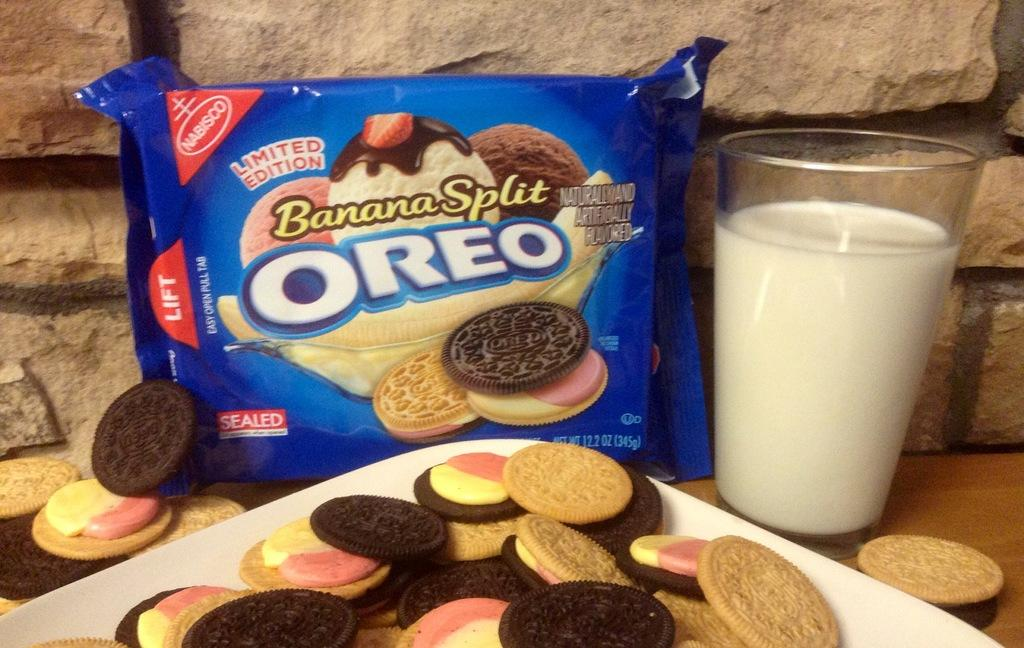What is the main subject of the image? The main subject of the image is an Oreo biscuit packet. What else can be seen on the plate in the image? There are biscuits on a white plate in the image. What is the liquid in the glass in the image? There is a glass of milk in the image. What type of material is the wall made of in the background of the image? There is a granite wall in the background of the image. What type of skirt is hanging on the granite wall in the image? There is no skirt present in the image; it features an Oreo biscuit packet, biscuits on a plate, a glass of milk, and a granite wall in the background. 